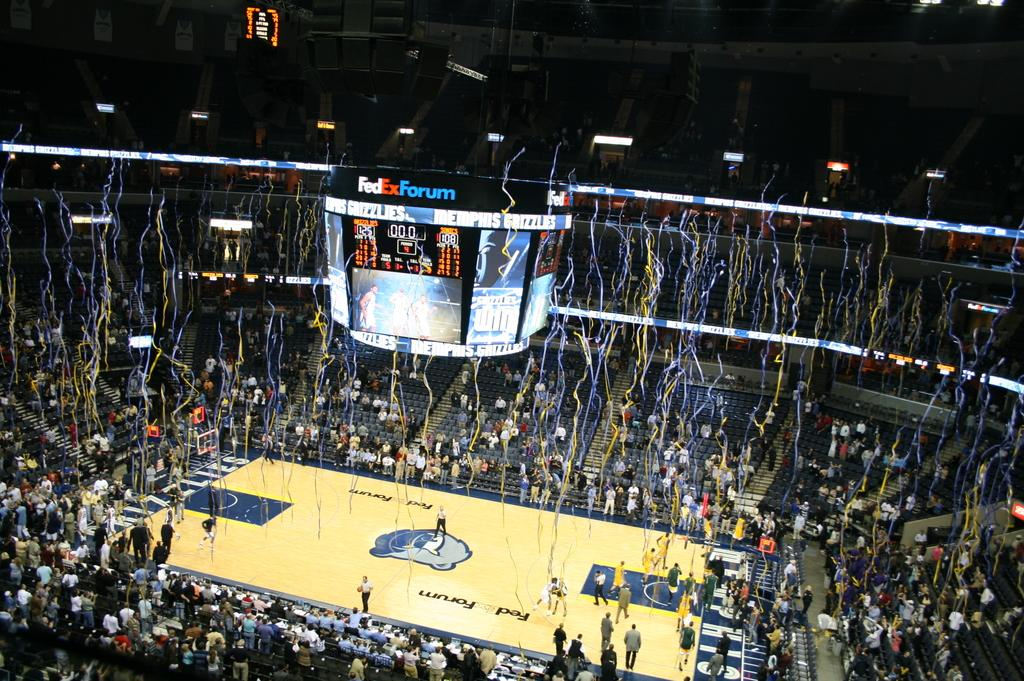<image>
Offer a succinct explanation of the picture presented. Basketball stadium named FedEx Forum celebrating after a win. 